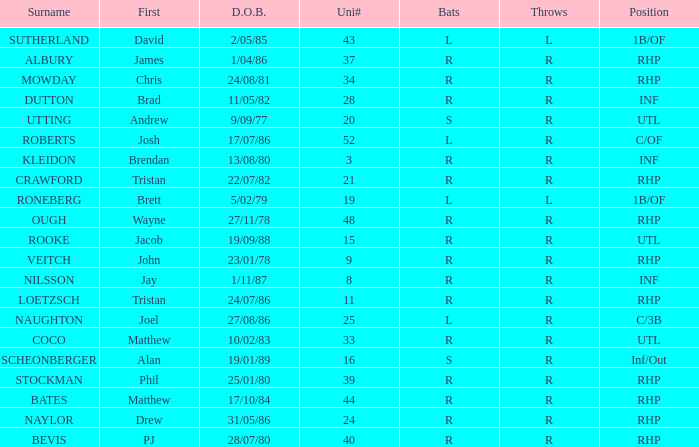How many Uni numbers have Bats of s, and a Position of utl? 1.0. 